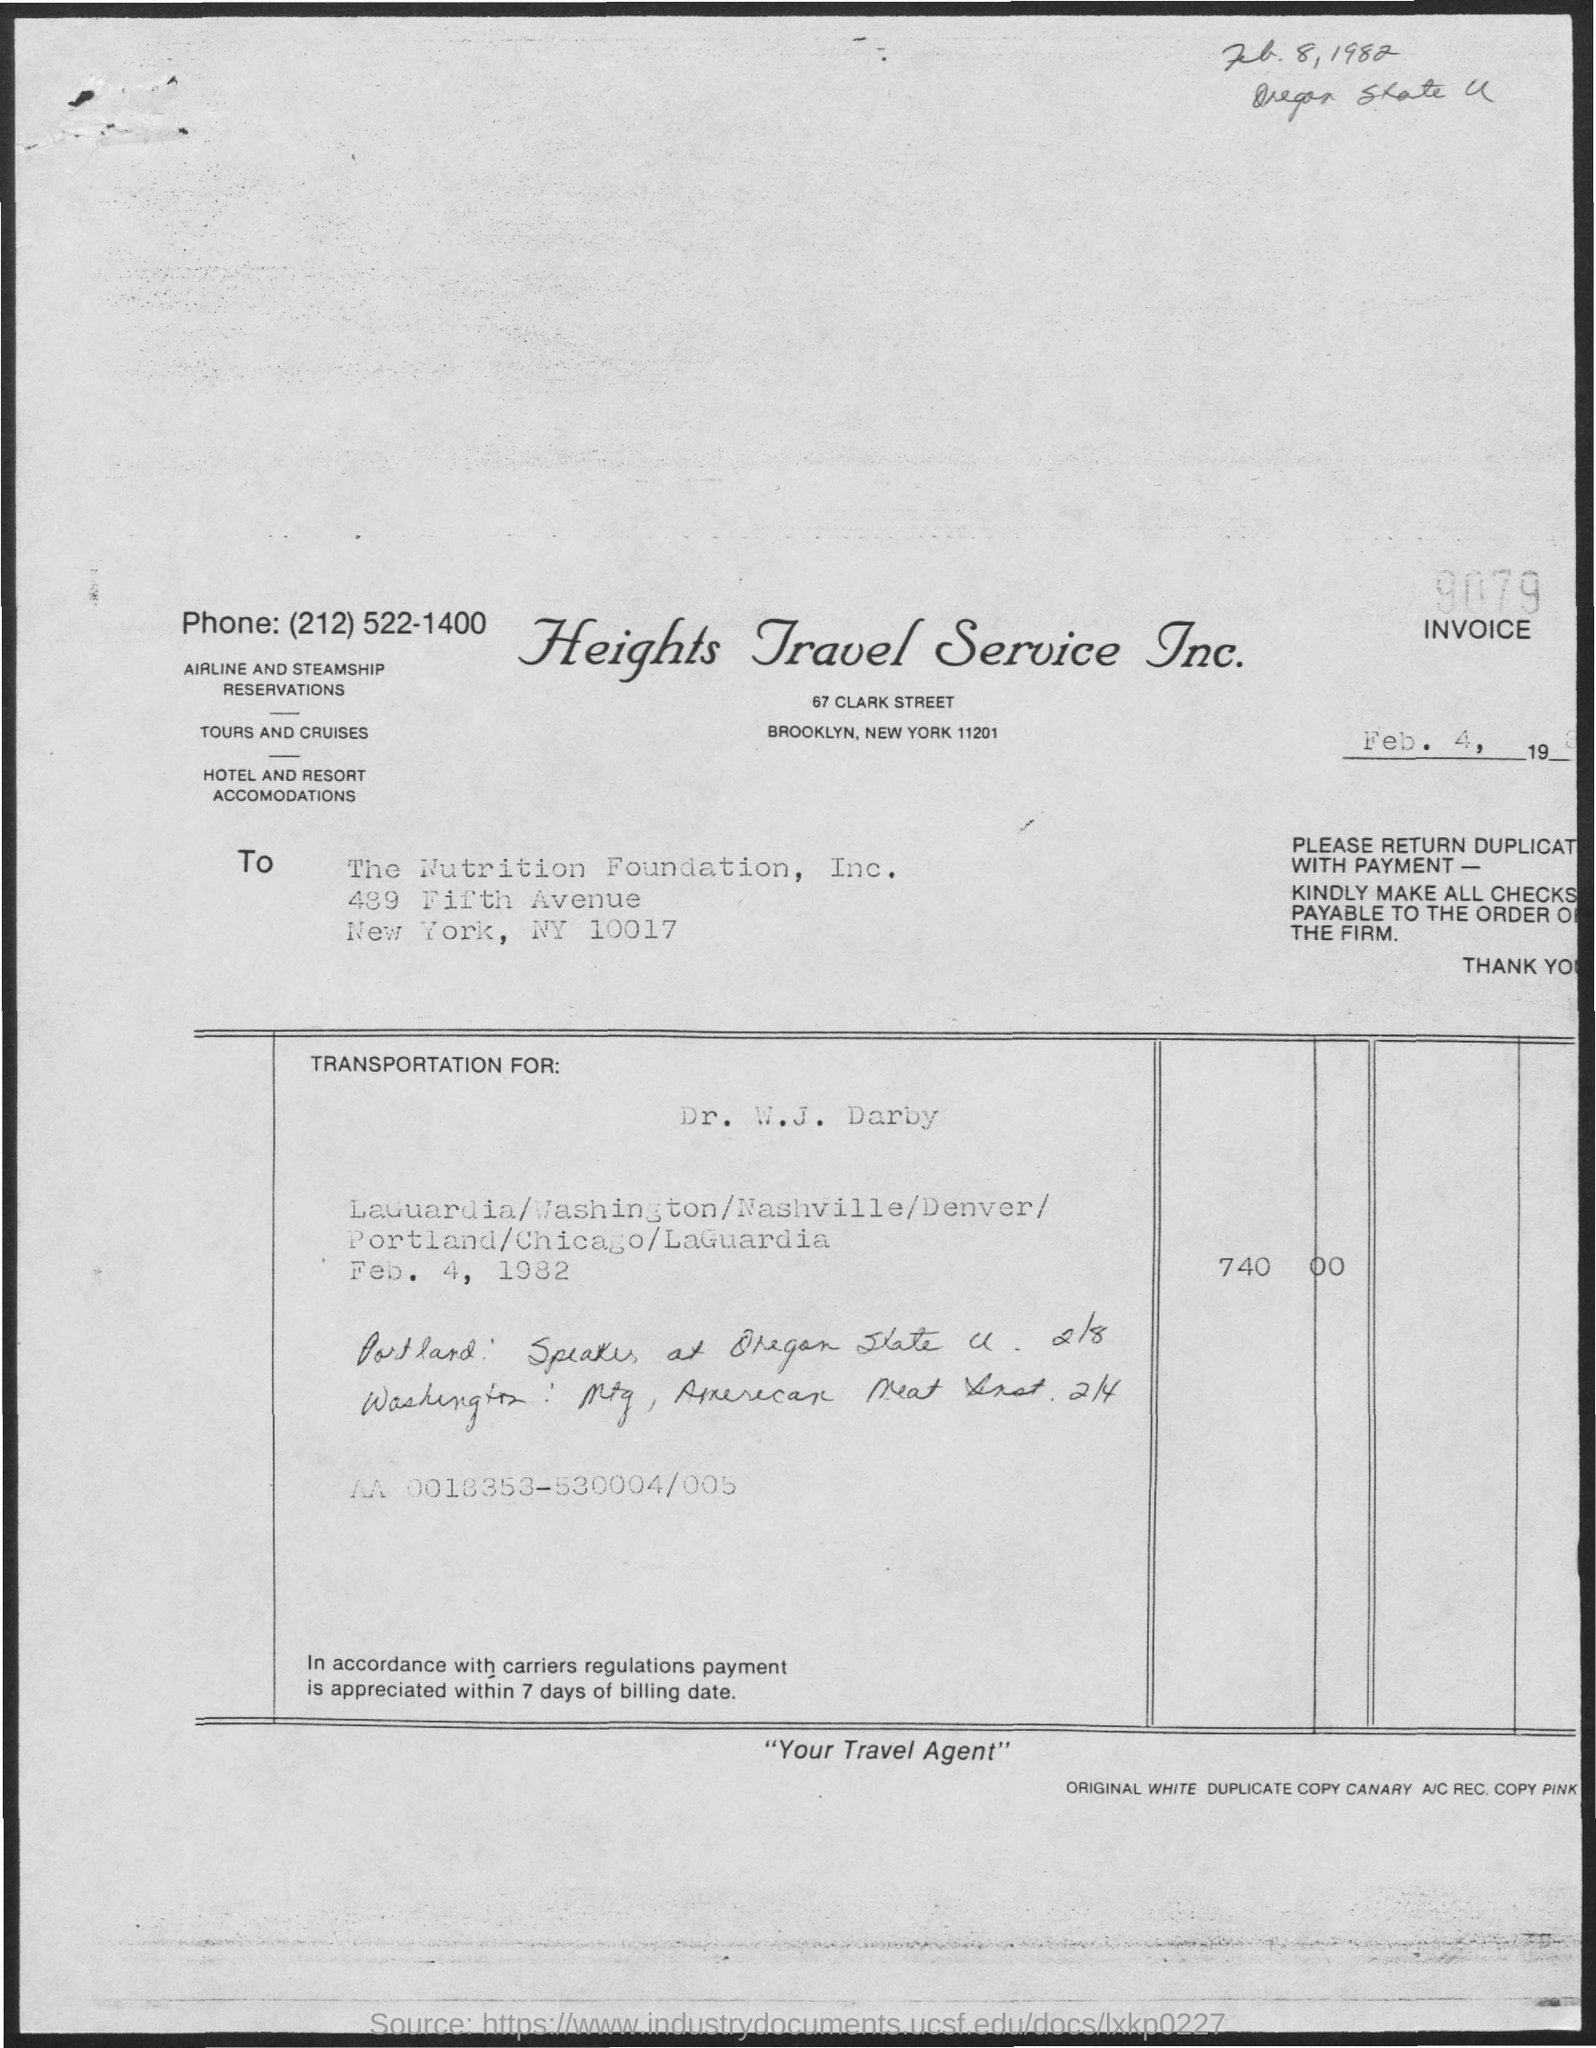Draw attention to some important aspects in this diagram. The document title is 'What is the title of the document? heights travel service inc...' The handwritten date at the top of the document is "February 8, 1982. The date mentioned inside the box is February 4, 1982. The invoice number is 9079. 